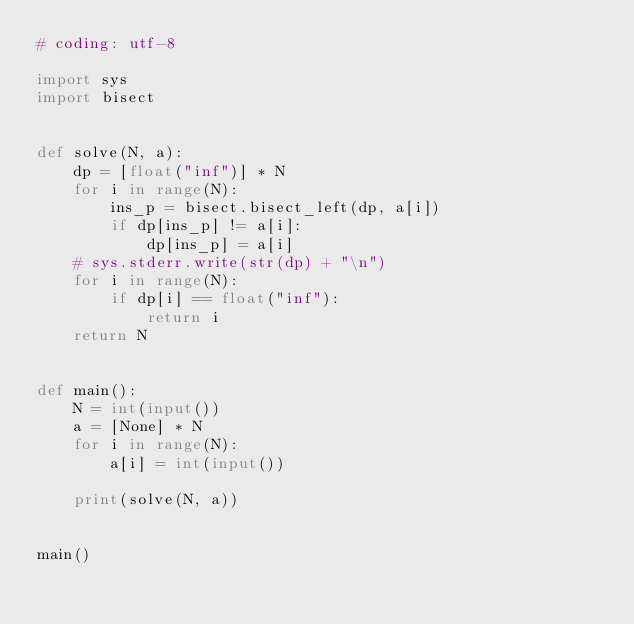<code> <loc_0><loc_0><loc_500><loc_500><_Python_># coding: utf-8

import sys
import bisect


def solve(N, a):
    dp = [float("inf")] * N
    for i in range(N):
        ins_p = bisect.bisect_left(dp, a[i])
        if dp[ins_p] != a[i]:
            dp[ins_p] = a[i]
    # sys.stderr.write(str(dp) + "\n")
    for i in range(N):
        if dp[i] == float("inf"):
            return i
    return N


def main():
    N = int(input())
    a = [None] * N
    for i in range(N):
        a[i] = int(input())

    print(solve(N, a))


main()</code> 